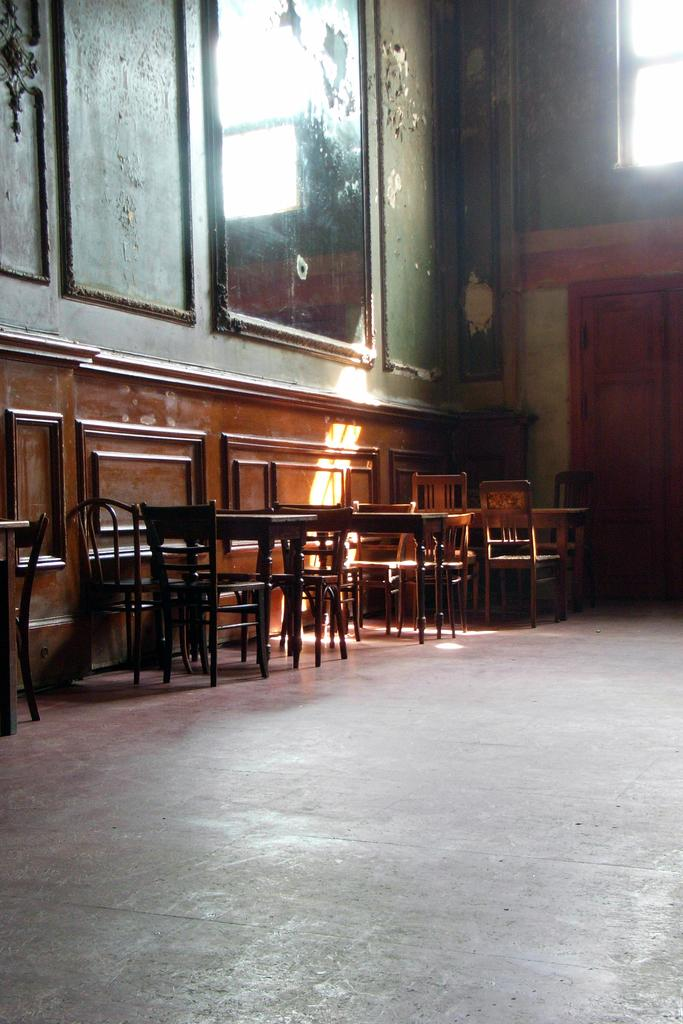What part of a building is visible in the image? The image shows the inner part of a building. What type of furniture can be seen in the image? There are chairs and tables in the image. Are there any openings to the outside in the image? Yes, there is a door and a window in the image. What is attached to the wall in the image? There are frames attached to the wall in the image. How many brothers are sitting on the chairs in the image? There is no mention of brothers or anyone sitting on the chairs in the image. What letters are written on the frames in the image? There is no information about letters or any writing on the frames in the image. 